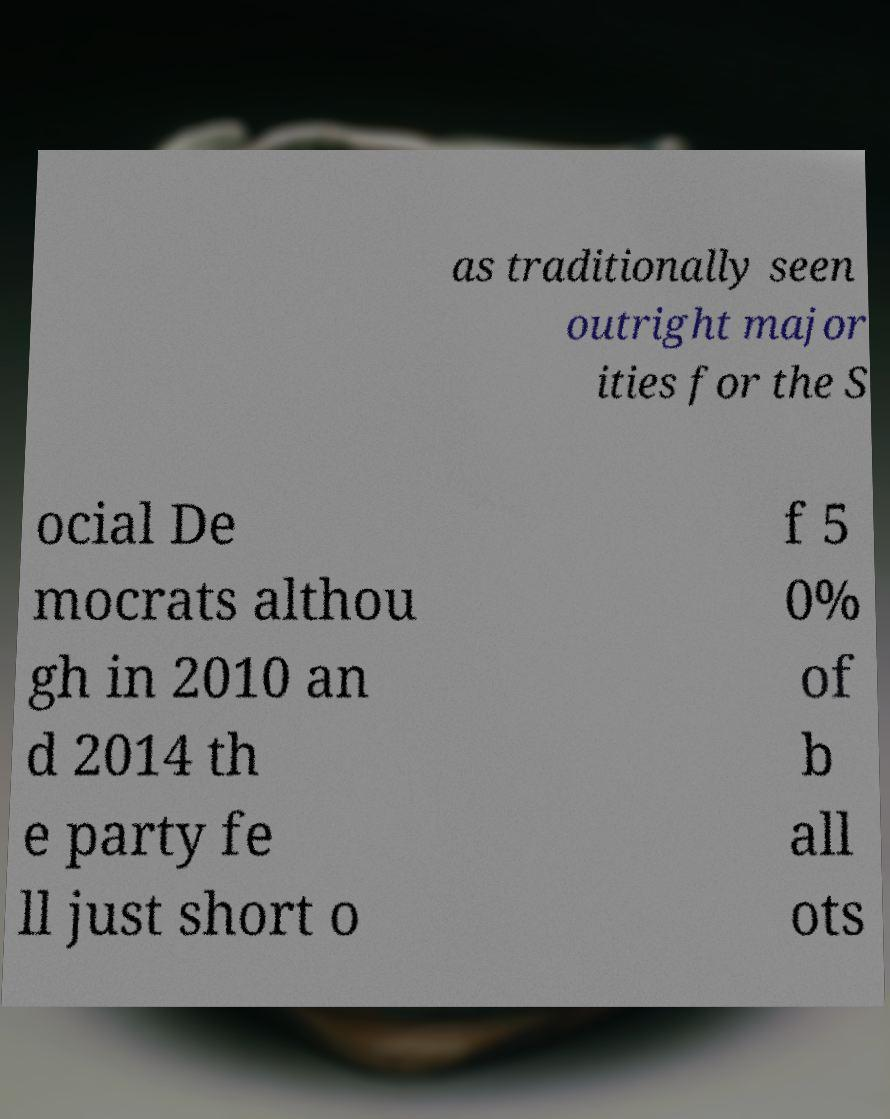Could you assist in decoding the text presented in this image and type it out clearly? as traditionally seen outright major ities for the S ocial De mocrats althou gh in 2010 an d 2014 th e party fe ll just short o f 5 0% of b all ots 